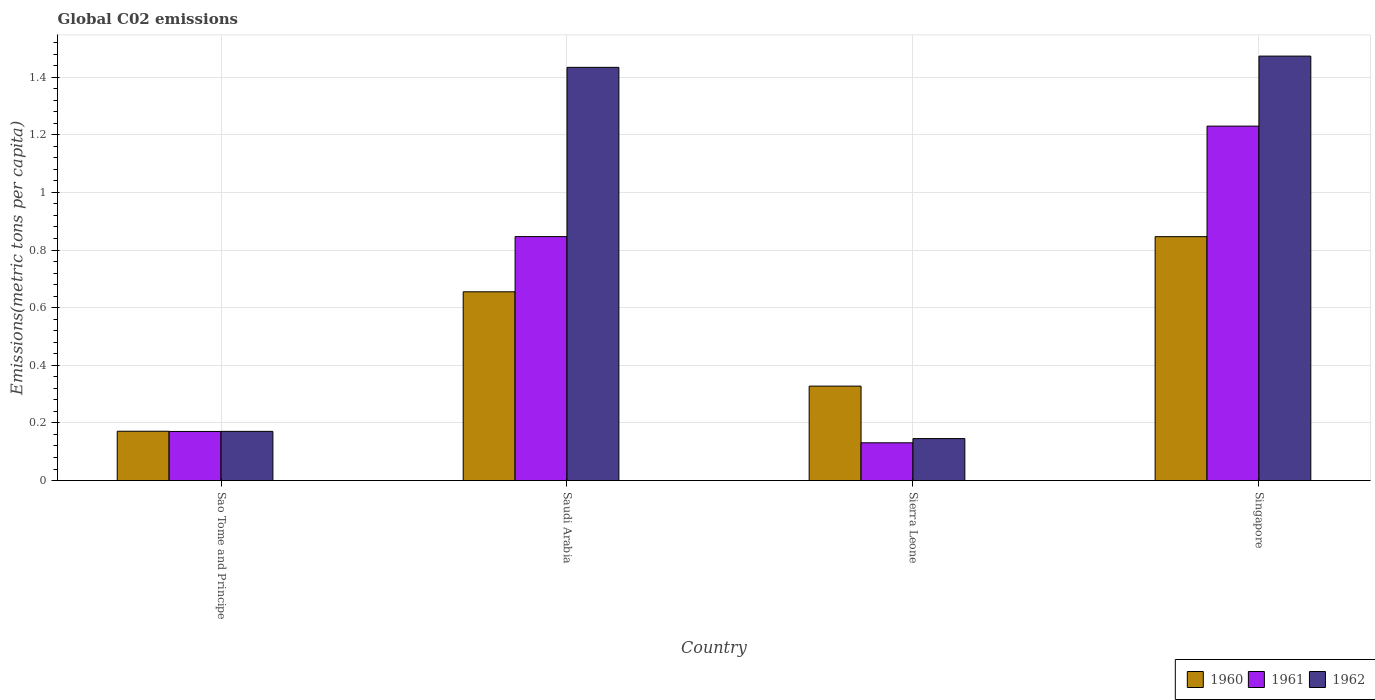Are the number of bars per tick equal to the number of legend labels?
Ensure brevity in your answer.  Yes. Are the number of bars on each tick of the X-axis equal?
Your response must be concise. Yes. What is the label of the 3rd group of bars from the left?
Provide a short and direct response. Sierra Leone. In how many cases, is the number of bars for a given country not equal to the number of legend labels?
Keep it short and to the point. 0. What is the amount of CO2 emitted in in 1962 in Sierra Leone?
Offer a terse response. 0.15. Across all countries, what is the maximum amount of CO2 emitted in in 1960?
Your answer should be compact. 0.85. Across all countries, what is the minimum amount of CO2 emitted in in 1961?
Your answer should be compact. 0.13. In which country was the amount of CO2 emitted in in 1961 maximum?
Provide a succinct answer. Singapore. In which country was the amount of CO2 emitted in in 1960 minimum?
Offer a very short reply. Sao Tome and Principe. What is the total amount of CO2 emitted in in 1962 in the graph?
Provide a short and direct response. 3.22. What is the difference between the amount of CO2 emitted in in 1961 in Saudi Arabia and that in Sierra Leone?
Give a very brief answer. 0.72. What is the difference between the amount of CO2 emitted in in 1962 in Singapore and the amount of CO2 emitted in in 1960 in Sao Tome and Principe?
Offer a very short reply. 1.3. What is the average amount of CO2 emitted in in 1960 per country?
Give a very brief answer. 0.5. What is the difference between the amount of CO2 emitted in of/in 1960 and amount of CO2 emitted in of/in 1962 in Saudi Arabia?
Make the answer very short. -0.78. In how many countries, is the amount of CO2 emitted in in 1960 greater than 0.16 metric tons per capita?
Keep it short and to the point. 4. What is the ratio of the amount of CO2 emitted in in 1961 in Saudi Arabia to that in Sierra Leone?
Give a very brief answer. 6.46. Is the amount of CO2 emitted in in 1961 in Sao Tome and Principe less than that in Sierra Leone?
Ensure brevity in your answer.  No. What is the difference between the highest and the second highest amount of CO2 emitted in in 1960?
Provide a short and direct response. 0.19. What is the difference between the highest and the lowest amount of CO2 emitted in in 1961?
Keep it short and to the point. 1.1. Is it the case that in every country, the sum of the amount of CO2 emitted in in 1961 and amount of CO2 emitted in in 1960 is greater than the amount of CO2 emitted in in 1962?
Provide a short and direct response. Yes. Does the graph contain grids?
Your answer should be very brief. Yes. Where does the legend appear in the graph?
Provide a short and direct response. Bottom right. How are the legend labels stacked?
Ensure brevity in your answer.  Horizontal. What is the title of the graph?
Provide a short and direct response. Global C02 emissions. Does "1973" appear as one of the legend labels in the graph?
Your response must be concise. No. What is the label or title of the X-axis?
Provide a short and direct response. Country. What is the label or title of the Y-axis?
Keep it short and to the point. Emissions(metric tons per capita). What is the Emissions(metric tons per capita) of 1960 in Sao Tome and Principe?
Your answer should be compact. 0.17. What is the Emissions(metric tons per capita) in 1961 in Sao Tome and Principe?
Provide a succinct answer. 0.17. What is the Emissions(metric tons per capita) of 1962 in Sao Tome and Principe?
Provide a succinct answer. 0.17. What is the Emissions(metric tons per capita) in 1960 in Saudi Arabia?
Your answer should be very brief. 0.66. What is the Emissions(metric tons per capita) in 1961 in Saudi Arabia?
Your response must be concise. 0.85. What is the Emissions(metric tons per capita) of 1962 in Saudi Arabia?
Give a very brief answer. 1.43. What is the Emissions(metric tons per capita) in 1960 in Sierra Leone?
Offer a terse response. 0.33. What is the Emissions(metric tons per capita) in 1961 in Sierra Leone?
Your answer should be compact. 0.13. What is the Emissions(metric tons per capita) of 1962 in Sierra Leone?
Ensure brevity in your answer.  0.15. What is the Emissions(metric tons per capita) of 1960 in Singapore?
Provide a short and direct response. 0.85. What is the Emissions(metric tons per capita) in 1961 in Singapore?
Provide a short and direct response. 1.23. What is the Emissions(metric tons per capita) in 1962 in Singapore?
Your answer should be very brief. 1.47. Across all countries, what is the maximum Emissions(metric tons per capita) of 1960?
Provide a succinct answer. 0.85. Across all countries, what is the maximum Emissions(metric tons per capita) of 1961?
Your response must be concise. 1.23. Across all countries, what is the maximum Emissions(metric tons per capita) in 1962?
Provide a short and direct response. 1.47. Across all countries, what is the minimum Emissions(metric tons per capita) of 1960?
Give a very brief answer. 0.17. Across all countries, what is the minimum Emissions(metric tons per capita) of 1961?
Offer a very short reply. 0.13. Across all countries, what is the minimum Emissions(metric tons per capita) of 1962?
Provide a short and direct response. 0.15. What is the total Emissions(metric tons per capita) in 1960 in the graph?
Keep it short and to the point. 2. What is the total Emissions(metric tons per capita) in 1961 in the graph?
Make the answer very short. 2.38. What is the total Emissions(metric tons per capita) in 1962 in the graph?
Give a very brief answer. 3.22. What is the difference between the Emissions(metric tons per capita) of 1960 in Sao Tome and Principe and that in Saudi Arabia?
Ensure brevity in your answer.  -0.48. What is the difference between the Emissions(metric tons per capita) of 1961 in Sao Tome and Principe and that in Saudi Arabia?
Keep it short and to the point. -0.68. What is the difference between the Emissions(metric tons per capita) in 1962 in Sao Tome and Principe and that in Saudi Arabia?
Your answer should be very brief. -1.26. What is the difference between the Emissions(metric tons per capita) of 1960 in Sao Tome and Principe and that in Sierra Leone?
Provide a succinct answer. -0.16. What is the difference between the Emissions(metric tons per capita) of 1961 in Sao Tome and Principe and that in Sierra Leone?
Ensure brevity in your answer.  0.04. What is the difference between the Emissions(metric tons per capita) of 1962 in Sao Tome and Principe and that in Sierra Leone?
Provide a short and direct response. 0.03. What is the difference between the Emissions(metric tons per capita) of 1960 in Sao Tome and Principe and that in Singapore?
Provide a succinct answer. -0.68. What is the difference between the Emissions(metric tons per capita) of 1961 in Sao Tome and Principe and that in Singapore?
Your response must be concise. -1.06. What is the difference between the Emissions(metric tons per capita) of 1962 in Sao Tome and Principe and that in Singapore?
Provide a succinct answer. -1.3. What is the difference between the Emissions(metric tons per capita) of 1960 in Saudi Arabia and that in Sierra Leone?
Your answer should be very brief. 0.33. What is the difference between the Emissions(metric tons per capita) in 1961 in Saudi Arabia and that in Sierra Leone?
Keep it short and to the point. 0.72. What is the difference between the Emissions(metric tons per capita) in 1962 in Saudi Arabia and that in Sierra Leone?
Keep it short and to the point. 1.29. What is the difference between the Emissions(metric tons per capita) of 1960 in Saudi Arabia and that in Singapore?
Offer a terse response. -0.19. What is the difference between the Emissions(metric tons per capita) in 1961 in Saudi Arabia and that in Singapore?
Offer a terse response. -0.38. What is the difference between the Emissions(metric tons per capita) in 1962 in Saudi Arabia and that in Singapore?
Offer a very short reply. -0.04. What is the difference between the Emissions(metric tons per capita) of 1960 in Sierra Leone and that in Singapore?
Provide a short and direct response. -0.52. What is the difference between the Emissions(metric tons per capita) of 1961 in Sierra Leone and that in Singapore?
Offer a terse response. -1.1. What is the difference between the Emissions(metric tons per capita) in 1962 in Sierra Leone and that in Singapore?
Provide a short and direct response. -1.33. What is the difference between the Emissions(metric tons per capita) in 1960 in Sao Tome and Principe and the Emissions(metric tons per capita) in 1961 in Saudi Arabia?
Offer a terse response. -0.68. What is the difference between the Emissions(metric tons per capita) in 1960 in Sao Tome and Principe and the Emissions(metric tons per capita) in 1962 in Saudi Arabia?
Offer a terse response. -1.26. What is the difference between the Emissions(metric tons per capita) of 1961 in Sao Tome and Principe and the Emissions(metric tons per capita) of 1962 in Saudi Arabia?
Offer a terse response. -1.26. What is the difference between the Emissions(metric tons per capita) of 1960 in Sao Tome and Principe and the Emissions(metric tons per capita) of 1961 in Sierra Leone?
Ensure brevity in your answer.  0.04. What is the difference between the Emissions(metric tons per capita) of 1960 in Sao Tome and Principe and the Emissions(metric tons per capita) of 1962 in Sierra Leone?
Offer a very short reply. 0.03. What is the difference between the Emissions(metric tons per capita) of 1961 in Sao Tome and Principe and the Emissions(metric tons per capita) of 1962 in Sierra Leone?
Your answer should be very brief. 0.02. What is the difference between the Emissions(metric tons per capita) of 1960 in Sao Tome and Principe and the Emissions(metric tons per capita) of 1961 in Singapore?
Provide a succinct answer. -1.06. What is the difference between the Emissions(metric tons per capita) in 1960 in Sao Tome and Principe and the Emissions(metric tons per capita) in 1962 in Singapore?
Make the answer very short. -1.3. What is the difference between the Emissions(metric tons per capita) of 1961 in Sao Tome and Principe and the Emissions(metric tons per capita) of 1962 in Singapore?
Make the answer very short. -1.3. What is the difference between the Emissions(metric tons per capita) in 1960 in Saudi Arabia and the Emissions(metric tons per capita) in 1961 in Sierra Leone?
Offer a very short reply. 0.52. What is the difference between the Emissions(metric tons per capita) of 1960 in Saudi Arabia and the Emissions(metric tons per capita) of 1962 in Sierra Leone?
Your answer should be compact. 0.51. What is the difference between the Emissions(metric tons per capita) of 1961 in Saudi Arabia and the Emissions(metric tons per capita) of 1962 in Sierra Leone?
Your answer should be compact. 0.7. What is the difference between the Emissions(metric tons per capita) in 1960 in Saudi Arabia and the Emissions(metric tons per capita) in 1961 in Singapore?
Offer a very short reply. -0.57. What is the difference between the Emissions(metric tons per capita) in 1960 in Saudi Arabia and the Emissions(metric tons per capita) in 1962 in Singapore?
Offer a terse response. -0.82. What is the difference between the Emissions(metric tons per capita) in 1961 in Saudi Arabia and the Emissions(metric tons per capita) in 1962 in Singapore?
Provide a succinct answer. -0.63. What is the difference between the Emissions(metric tons per capita) in 1960 in Sierra Leone and the Emissions(metric tons per capita) in 1961 in Singapore?
Your answer should be very brief. -0.9. What is the difference between the Emissions(metric tons per capita) in 1960 in Sierra Leone and the Emissions(metric tons per capita) in 1962 in Singapore?
Provide a succinct answer. -1.15. What is the difference between the Emissions(metric tons per capita) of 1961 in Sierra Leone and the Emissions(metric tons per capita) of 1962 in Singapore?
Provide a short and direct response. -1.34. What is the average Emissions(metric tons per capita) in 1960 per country?
Provide a succinct answer. 0.5. What is the average Emissions(metric tons per capita) in 1961 per country?
Your answer should be compact. 0.59. What is the average Emissions(metric tons per capita) of 1962 per country?
Offer a terse response. 0.81. What is the difference between the Emissions(metric tons per capita) in 1960 and Emissions(metric tons per capita) in 1961 in Sao Tome and Principe?
Make the answer very short. 0. What is the difference between the Emissions(metric tons per capita) of 1960 and Emissions(metric tons per capita) of 1962 in Sao Tome and Principe?
Your answer should be very brief. 0. What is the difference between the Emissions(metric tons per capita) in 1961 and Emissions(metric tons per capita) in 1962 in Sao Tome and Principe?
Provide a succinct answer. -0. What is the difference between the Emissions(metric tons per capita) of 1960 and Emissions(metric tons per capita) of 1961 in Saudi Arabia?
Your answer should be compact. -0.19. What is the difference between the Emissions(metric tons per capita) in 1960 and Emissions(metric tons per capita) in 1962 in Saudi Arabia?
Provide a short and direct response. -0.78. What is the difference between the Emissions(metric tons per capita) in 1961 and Emissions(metric tons per capita) in 1962 in Saudi Arabia?
Give a very brief answer. -0.59. What is the difference between the Emissions(metric tons per capita) in 1960 and Emissions(metric tons per capita) in 1961 in Sierra Leone?
Provide a short and direct response. 0.2. What is the difference between the Emissions(metric tons per capita) in 1960 and Emissions(metric tons per capita) in 1962 in Sierra Leone?
Make the answer very short. 0.18. What is the difference between the Emissions(metric tons per capita) in 1961 and Emissions(metric tons per capita) in 1962 in Sierra Leone?
Your answer should be compact. -0.01. What is the difference between the Emissions(metric tons per capita) of 1960 and Emissions(metric tons per capita) of 1961 in Singapore?
Your response must be concise. -0.38. What is the difference between the Emissions(metric tons per capita) of 1960 and Emissions(metric tons per capita) of 1962 in Singapore?
Your answer should be compact. -0.63. What is the difference between the Emissions(metric tons per capita) in 1961 and Emissions(metric tons per capita) in 1962 in Singapore?
Give a very brief answer. -0.24. What is the ratio of the Emissions(metric tons per capita) in 1960 in Sao Tome and Principe to that in Saudi Arabia?
Give a very brief answer. 0.26. What is the ratio of the Emissions(metric tons per capita) in 1961 in Sao Tome and Principe to that in Saudi Arabia?
Your answer should be very brief. 0.2. What is the ratio of the Emissions(metric tons per capita) in 1962 in Sao Tome and Principe to that in Saudi Arabia?
Your answer should be compact. 0.12. What is the ratio of the Emissions(metric tons per capita) of 1960 in Sao Tome and Principe to that in Sierra Leone?
Offer a terse response. 0.52. What is the ratio of the Emissions(metric tons per capita) in 1961 in Sao Tome and Principe to that in Sierra Leone?
Offer a terse response. 1.3. What is the ratio of the Emissions(metric tons per capita) in 1962 in Sao Tome and Principe to that in Sierra Leone?
Offer a very short reply. 1.17. What is the ratio of the Emissions(metric tons per capita) in 1960 in Sao Tome and Principe to that in Singapore?
Your answer should be very brief. 0.2. What is the ratio of the Emissions(metric tons per capita) of 1961 in Sao Tome and Principe to that in Singapore?
Provide a succinct answer. 0.14. What is the ratio of the Emissions(metric tons per capita) in 1962 in Sao Tome and Principe to that in Singapore?
Your answer should be very brief. 0.12. What is the ratio of the Emissions(metric tons per capita) in 1960 in Saudi Arabia to that in Sierra Leone?
Give a very brief answer. 2. What is the ratio of the Emissions(metric tons per capita) in 1961 in Saudi Arabia to that in Sierra Leone?
Your answer should be compact. 6.46. What is the ratio of the Emissions(metric tons per capita) of 1962 in Saudi Arabia to that in Sierra Leone?
Make the answer very short. 9.84. What is the ratio of the Emissions(metric tons per capita) in 1960 in Saudi Arabia to that in Singapore?
Ensure brevity in your answer.  0.77. What is the ratio of the Emissions(metric tons per capita) of 1961 in Saudi Arabia to that in Singapore?
Make the answer very short. 0.69. What is the ratio of the Emissions(metric tons per capita) in 1962 in Saudi Arabia to that in Singapore?
Offer a very short reply. 0.97. What is the ratio of the Emissions(metric tons per capita) of 1960 in Sierra Leone to that in Singapore?
Give a very brief answer. 0.39. What is the ratio of the Emissions(metric tons per capita) in 1961 in Sierra Leone to that in Singapore?
Offer a terse response. 0.11. What is the ratio of the Emissions(metric tons per capita) in 1962 in Sierra Leone to that in Singapore?
Make the answer very short. 0.1. What is the difference between the highest and the second highest Emissions(metric tons per capita) in 1960?
Ensure brevity in your answer.  0.19. What is the difference between the highest and the second highest Emissions(metric tons per capita) of 1961?
Provide a succinct answer. 0.38. What is the difference between the highest and the second highest Emissions(metric tons per capita) of 1962?
Your answer should be compact. 0.04. What is the difference between the highest and the lowest Emissions(metric tons per capita) of 1960?
Your answer should be very brief. 0.68. What is the difference between the highest and the lowest Emissions(metric tons per capita) in 1961?
Make the answer very short. 1.1. What is the difference between the highest and the lowest Emissions(metric tons per capita) in 1962?
Your answer should be very brief. 1.33. 